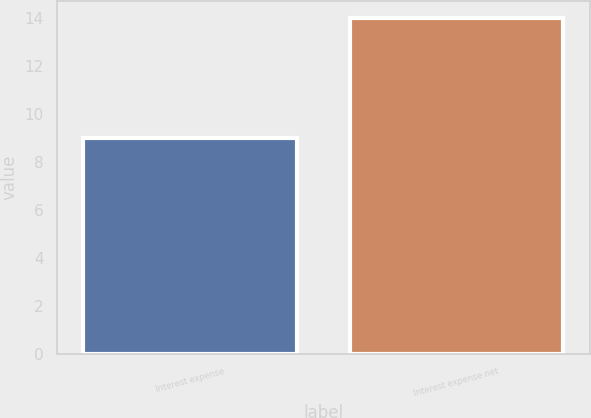Convert chart to OTSL. <chart><loc_0><loc_0><loc_500><loc_500><bar_chart><fcel>Interest expense<fcel>Interest expense net<nl><fcel>9<fcel>14<nl></chart> 